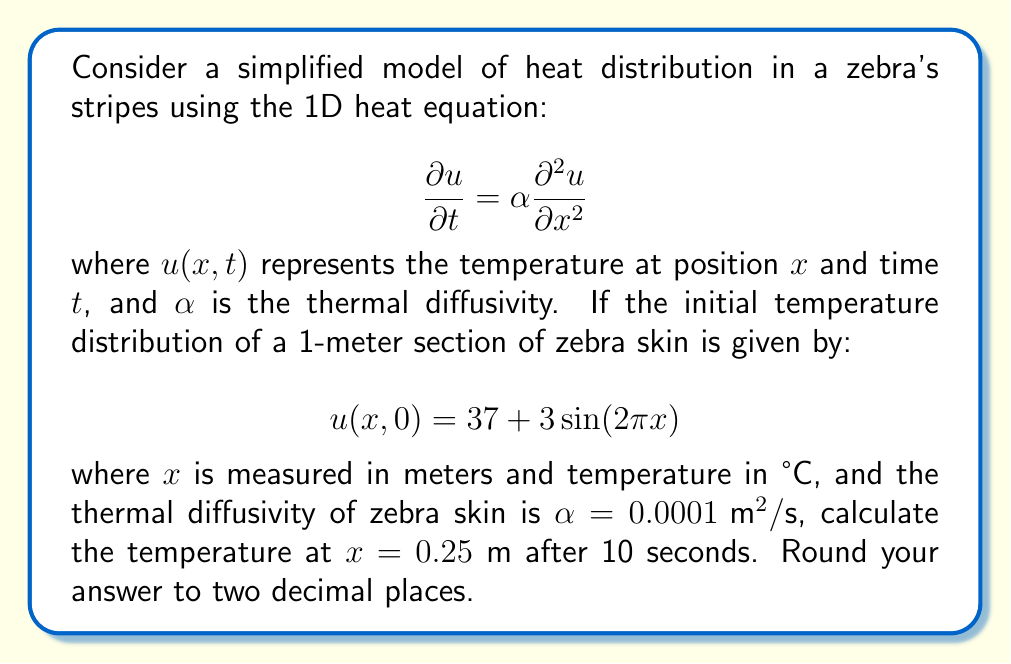Could you help me with this problem? To solve this problem, we'll use the solution to the 1D heat equation with periodic boundary conditions:

1) The general solution for the given initial condition is:

   $$u(x,t) = 37 + 3e^{-4\pi^2\alpha t}\sin(2\pi x)$$

2) We need to calculate $u(0.25, 10)$. Let's substitute the values:
   
   $x = 0.25$ m
   $t = 10$ s
   $\alpha = 0.0001 \text{ m}^2/\text{s}$

3) First, let's calculate the exponent:
   
   $$-4\pi^2\alpha t = -4\pi^2 \cdot 0.0001 \cdot 10 = -0.3948$$

4) Now, let's substitute everything into the equation:

   $$u(0.25, 10) = 37 + 3e^{-0.3948}\sin(2\pi \cdot 0.25)$$

5) Simplify:
   
   $$u(0.25, 10) = 37 + 3e^{-0.3948}\sin(\pi/2)$$
   $$u(0.25, 10) = 37 + 3e^{-0.3948} \cdot 1$$
   $$u(0.25, 10) = 37 + 3 \cdot 0.6738$$
   $$u(0.25, 10) = 37 + 2.0214$$
   $$u(0.25, 10) = 39.0214$$

6) Rounding to two decimal places:

   $$u(0.25, 10) \approx 39.02 \text{ °C}$$

This result shows how the heat has diffused over 10 seconds, reducing the temperature difference between the hot and cold stripes.
Answer: 39.02 °C 